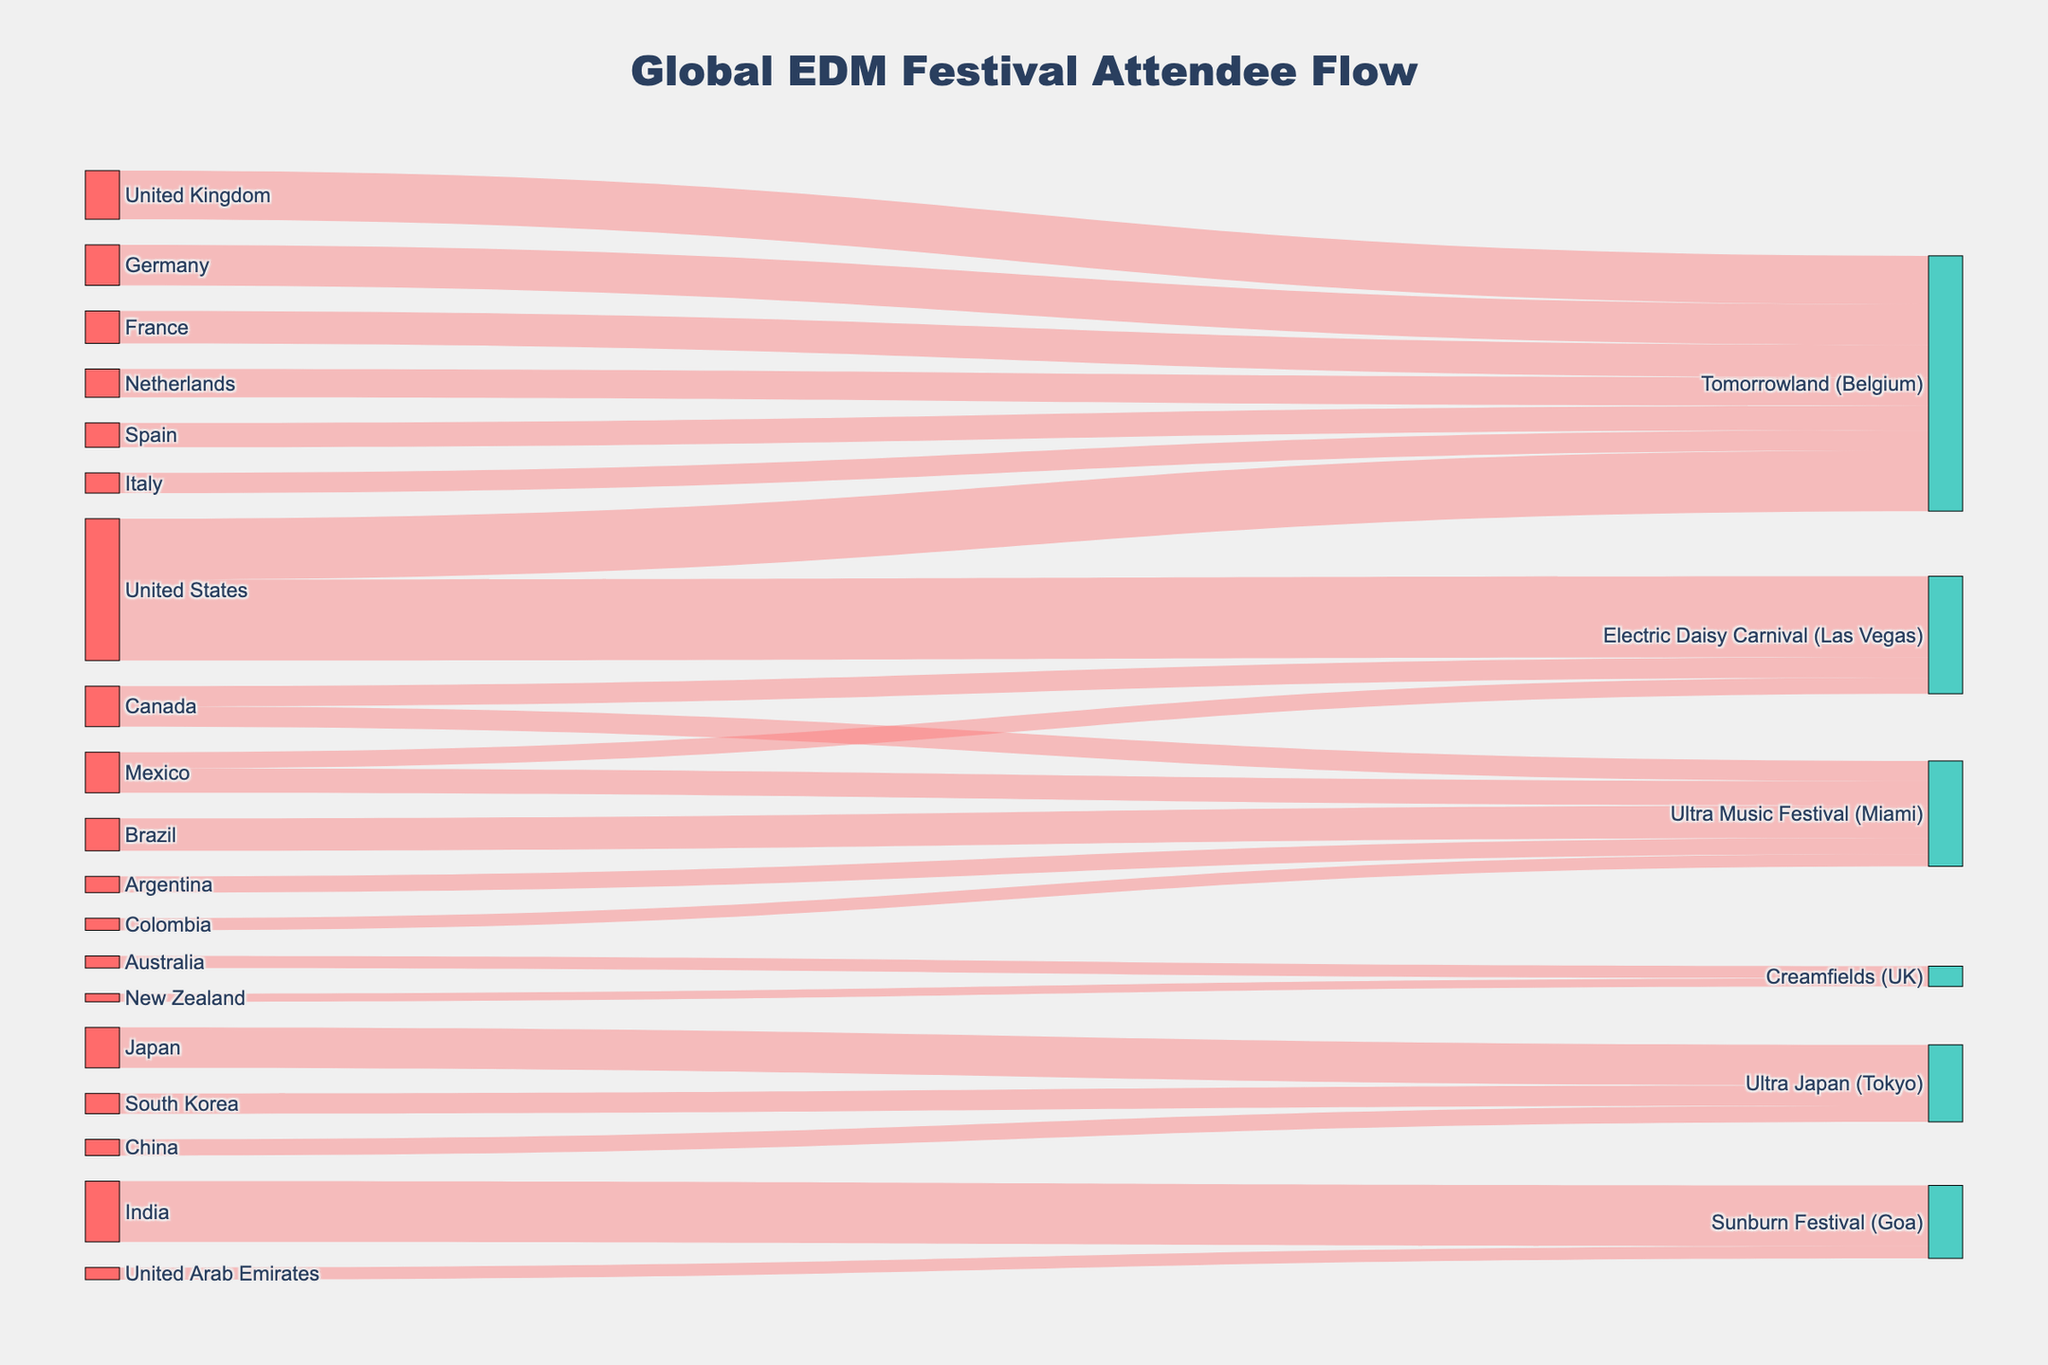Which festival has the highest number of attendees from a single country? Refer to the source list and look for the highest value connected to a single target. The United States has 20,000 attendees for the Electric Daisy Carnival in Las Vegas.
Answer: Electric Daisy Carnival (Las Vegas) Which two countries send the most attendees to Tomorrowland in Belgium? Check the values connected to Tomorrowland (Belgium) and find the two largest values. They are the United States with 15,000 and the United Kingdom with 12,000.
Answer: United States and United Kingdom How many attendees in total travel to Ultra Music Festival in Miami? Sum the values of all countries leading to Ultra Music Festival (Miami). 8,000 (Brazil) + 6,000 (Mexico) + 5,000 (Canada) + 4,000 (Argentina) + 3,000 (Colombia) = 26,000.
Answer: 26,000 From which country do the most attendees travel to Sunburn Festival in Goa? Identify the value of attendees from different countries going to Sunburn Festival (Goa) and find the highest. It is India with 15,000 attendees.
Answer: India What is the total number of attendees traveling from Canada? Sum all values originating from Canada. 5,000 (to Ultra Music Festival) + 5,000 (to Electric Daisy Carnival) = 10,000.
Answer: 10,000 Compare the number of attendees from the United States going to Tomorrowland (Belgium) vs Electric Daisy Carnival (Las Vegas). Look at the values connected to Tomorrowland (Belgium) and Electric Daisy Carnival (Las Vegas) from the United States. Tomorrowland (Belgium) has 15,000; Electric Daisy Carnival (Las Vegas) has 20,000.
Answer: Electric Daisy Carnival (Las Vegas) has 5,000 more Which destination has the least attendees from Japan? Japan is connected to Ultra Japan (Tokyo) with 10,000 attendees. This is the only connection, so there is no comparison possible.
Answer: Not applicable How many countries send attendees to Creamfields (UK)? Count the unique countries leading to Creamfields (UK) in the diagram. There are two: Australia and New Zealand.
Answer: 2 What is the difference in attendee numbers between Tomorrowland (Belgium) and Ultra Japan (Tokyo) from the source countries? Sum the total attendees for each festival and find the difference. Tomorrowland: 15000+12000+10000+8000+7000+6000+5000 = 63,000. Ultra Japan: 10000+5000+4000 = 19,000. Difference = 63,000 - 19,000 = 44,000.
Answer: 44,000 Which festival attracts the most diverse attendees in terms of different countries? Count the unique countries for each festival. Tomorrowland (Belgium) has attendees from 7 countries, Ultra Music Festival (Miami) from 5, Electric Daisy Carnival (Las Vegas) from 3, Creamfields (UK) from 2, Ultra Japan (Tokyo) from 3, and Sunburn Festival (Goa) from 2. Tomorrowland has the most diverse attendees.
Answer: Tomorrowland (Belgium) 